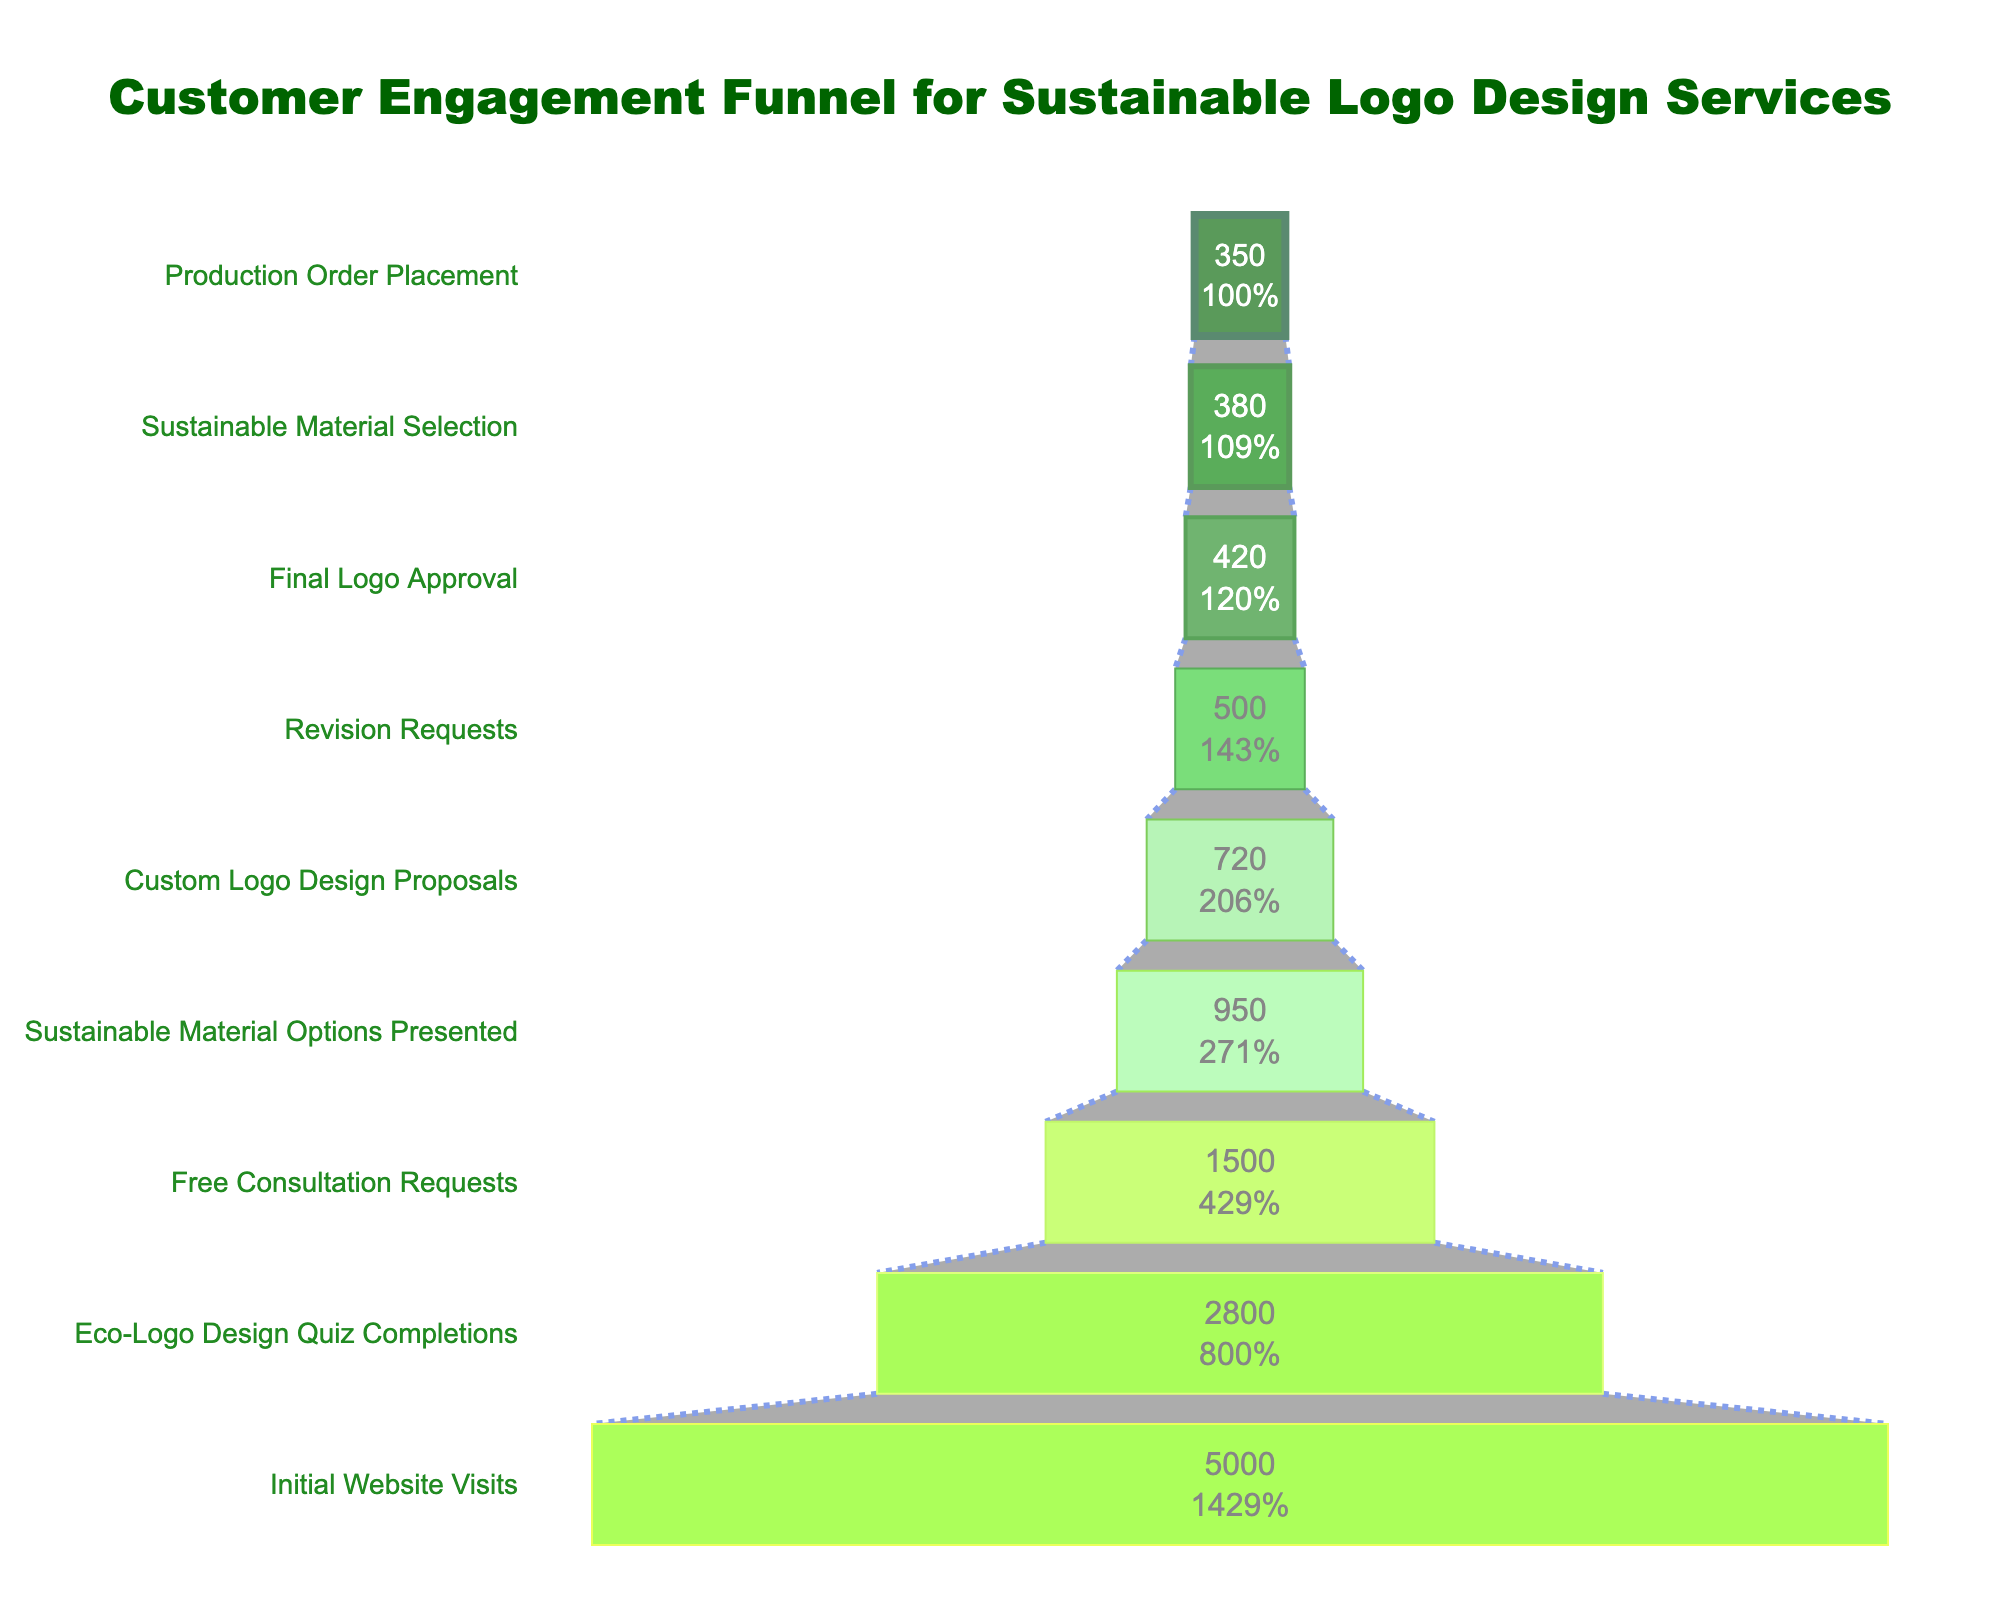what is the title of the figure? The title of the figure is displayed prominently at the top. It reads "Customer Engagement Funnel for Sustainable Logo Design Services."
Answer: Customer Engagement Funnel for Sustainable Logo Design Services How many initial website visits are there? The number of initial website visits is found at the broadest part of the funnel. It shows "5000."
Answer: 5000 What is the percentage of customers who moved from initial website visits to free consultation requests? First, identify the counts at the "Initial Website Visits" stage (5000) and "Free Consultation Requests" stage (1500). Calculate the percentage: (1500 / 5000) * 100 = 30%.
Answer: 30% Are there more free consultation requests or revision requests? Compare the values given for "Free Consultation Requests" and "Revision Requests." Free Consultation Requests are 1500, and Revision Requests are 500, so there are more Free Consultation Requests.
Answer: Free Consultation Requests What stage has the smallest count? The smallest count can be found by looking for the narrowest part of the funnel. It is "Production Order Placement," with 350.
Answer: Production Order Placement How many customers who requested free consultations eventually had custom logo design proposals presented to them? Compare the counts for "Free Consultation Requests" (1500) and "Custom Logo Design Proposals" (720). Find the difference: 1500 - 720 = 780. Therefore, 780 customers from the free consultations did not get to the proposal stage.
Answer: 780 What percentage of customers went from sustainable material selection to production order placement? First, identify the counts at the "Sustainable Material Selection" stage (380) and "Production Order Placement" stage (350). Calculate the percentage: (350 / 380) * 100 ≈ 92.11%.
Answer: 92.11% How many more customers completed the eco-logo design quiz than requested a free consultation? Compare the counts for "Eco-Logo Design Quiz Completions" (2800) and "Free Consultation Requests" (1500). Find the difference: 2800 - 1500 = 1300.
Answer: 1300 From free consultation requests to final logo approval, what is the total customer drop-off? Identify the counts at "Free Consultation Requests" (1500) and "Final Logo Approval" (420). Calculate the drop-off: 1500 - 420 = 1080.
Answer: 1080 What stage shows a 40% retention from the previous stage? For each stage, calculate the percentage retention from the previous stage. For "Custom Logo Design Proposals" (720) from "Sustainable Material Options Presented" (950): (720 / 950) * 100 ≈ 75.79%. Continue this for each stage until you find that "Revision Requests" (500) from "Custom Logo Design Proposals" (720) results in (500 / 720) * 100 ≈ 69.44%. Continue checking until "Final Logo Approval" (420) from "Revision Requests" (500): (420 / 500) * 100 = 84%. Thus, "Sustainable Material Selection" (380) from "Final Logo Approval" (420): (380 / 420) * 100 ≈ 90.48%, and finally "Production Order Placement" (350) from "Sustainable Material Selection" (380): (350 / 380) * 100 ≈ 92.11%. Hence, no stage shows exactly 40%. None of the stages show a 40% retention.
Answer: None 